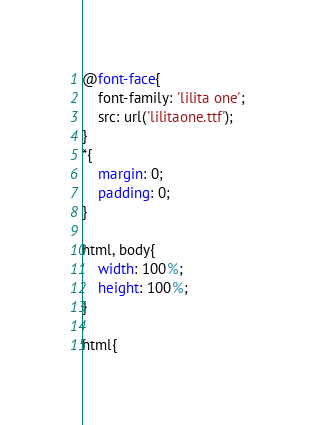<code> <loc_0><loc_0><loc_500><loc_500><_CSS_>@font-face{
    font-family: 'lilita one';
    src: url('lilitaone.ttf');
}
*{
    margin: 0;
    padding: 0;
}

html, body{
    width: 100%;
    height: 100%;
}

html{</code> 